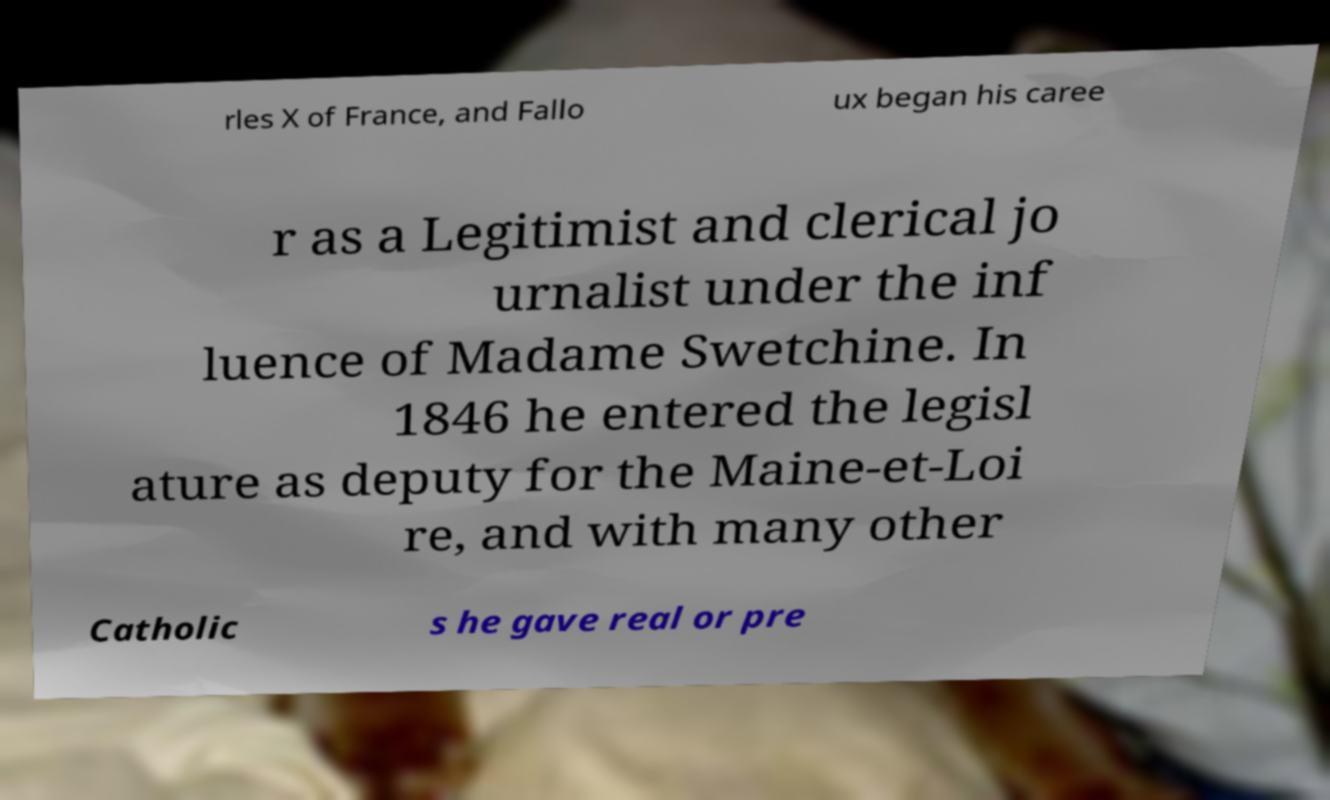I need the written content from this picture converted into text. Can you do that? rles X of France, and Fallo ux began his caree r as a Legitimist and clerical jo urnalist under the inf luence of Madame Swetchine. In 1846 he entered the legisl ature as deputy for the Maine-et-Loi re, and with many other Catholic s he gave real or pre 